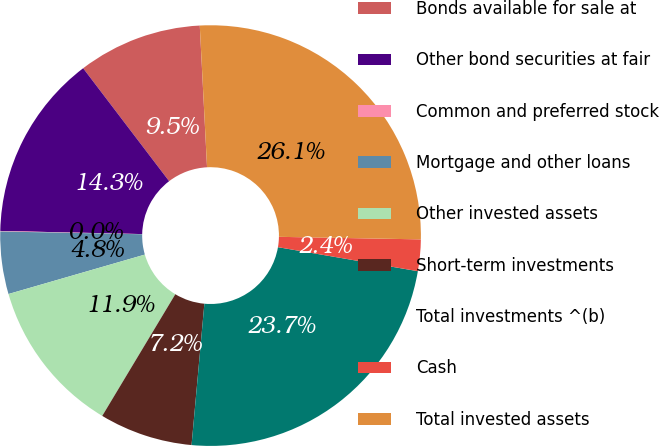Convert chart. <chart><loc_0><loc_0><loc_500><loc_500><pie_chart><fcel>Bonds available for sale at<fcel>Other bond securities at fair<fcel>Common and preferred stock<fcel>Mortgage and other loans<fcel>Other invested assets<fcel>Short-term investments<fcel>Total investments ^(b)<fcel>Cash<fcel>Total invested assets<nl><fcel>9.54%<fcel>14.29%<fcel>0.04%<fcel>4.79%<fcel>11.91%<fcel>7.17%<fcel>23.73%<fcel>2.42%<fcel>26.1%<nl></chart> 